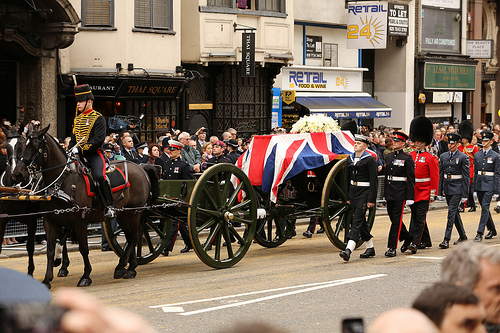What is pulled by the animal on the left? The animal on the left, which is a horse, is pulling a wagon. 